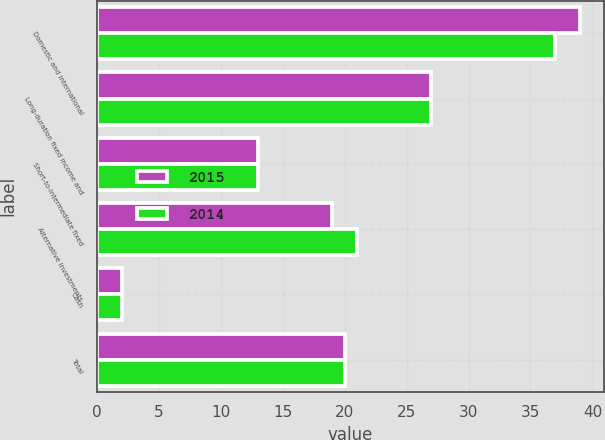<chart> <loc_0><loc_0><loc_500><loc_500><stacked_bar_chart><ecel><fcel>Domestic and international<fcel>Long-duration fixed income and<fcel>Short-to-intermediate fixed<fcel>Alternative investments<fcel>Cash<fcel>Total<nl><fcel>2015<fcel>39<fcel>27<fcel>13<fcel>19<fcel>2<fcel>20<nl><fcel>2014<fcel>37<fcel>27<fcel>13<fcel>21<fcel>2<fcel>20<nl></chart> 